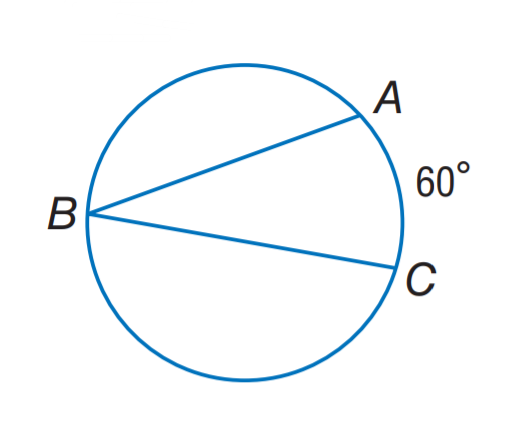Question: Find m \angle B.
Choices:
A. 20
B. 30
C. 60
D. 80
Answer with the letter. Answer: B 